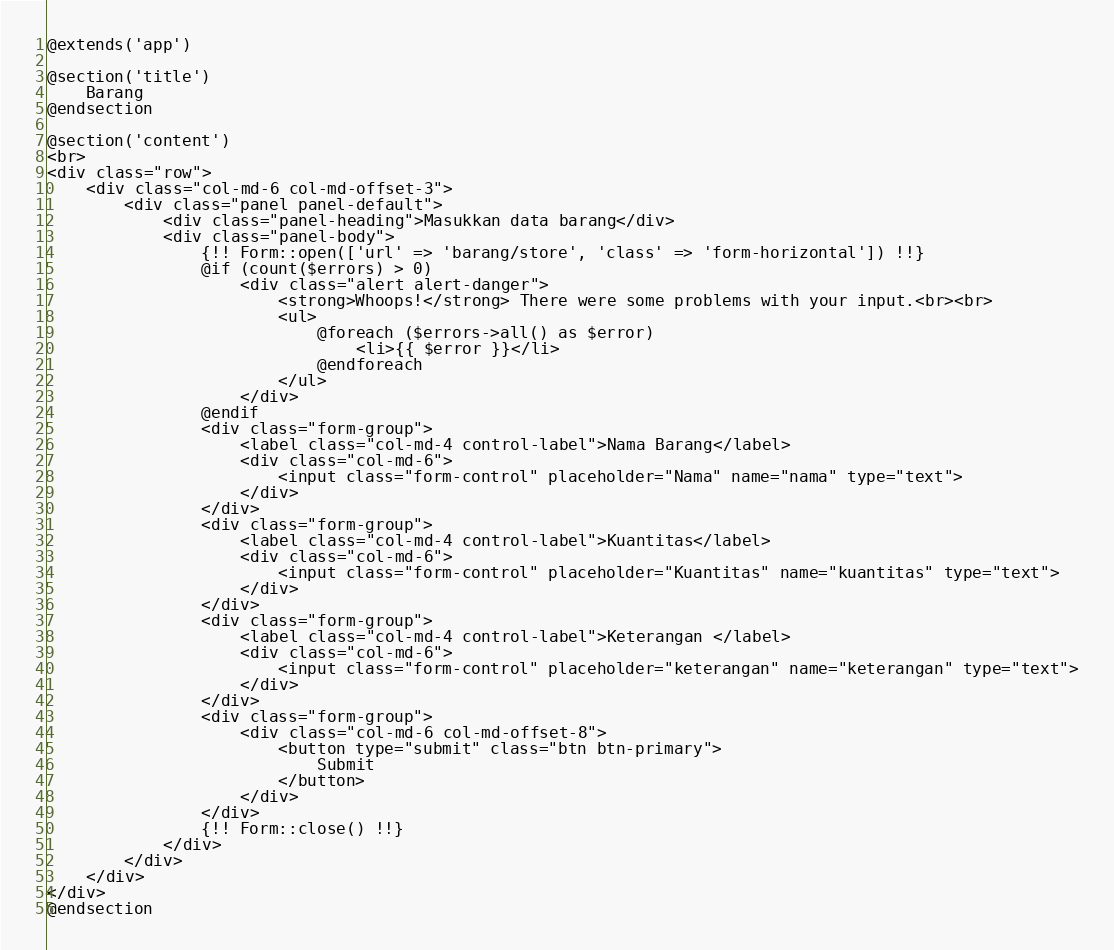<code> <loc_0><loc_0><loc_500><loc_500><_PHP_>@extends('app')

@section('title')
    Barang
@endsection

@section('content')
<br>
<div class="row">
    <div class="col-md-6 col-md-offset-3">
        <div class="panel panel-default">
            <div class="panel-heading">Masukkan data barang</div>
            <div class="panel-body">
                {!! Form::open(['url' => 'barang/store', 'class' => 'form-horizontal']) !!}
                @if (count($errors) > 0)
                    <div class="alert alert-danger">
                        <strong>Whoops!</strong> There were some problems with your input.<br><br>
                        <ul>
                            @foreach ($errors->all() as $error)
                                <li>{{ $error }}</li>
                            @endforeach
                        </ul>
                    </div>
                @endif
                <div class="form-group">
                    <label class="col-md-4 control-label">Nama Barang</label>
                    <div class="col-md-6">
                        <input class="form-control" placeholder="Nama" name="nama" type="text">
                    </div>
                </div>
                <div class="form-group">
                    <label class="col-md-4 control-label">Kuantitas</label>
                    <div class="col-md-6">
                        <input class="form-control" placeholder="Kuantitas" name="kuantitas" type="text">
                    </div>
                </div>
                <div class="form-group">
                    <label class="col-md-4 control-label">Keterangan </label>
                    <div class="col-md-6">
                        <input class="form-control" placeholder="keterangan" name="keterangan" type="text">
                    </div>
                </div>
                <div class="form-group">
                    <div class="col-md-6 col-md-offset-8">
                        <button type="submit" class="btn btn-primary">
                            Submit
                        </button>
                    </div>
                </div>
                {!! Form::close() !!}
            </div>
        </div>
    </div>
</div>
@endsection</code> 